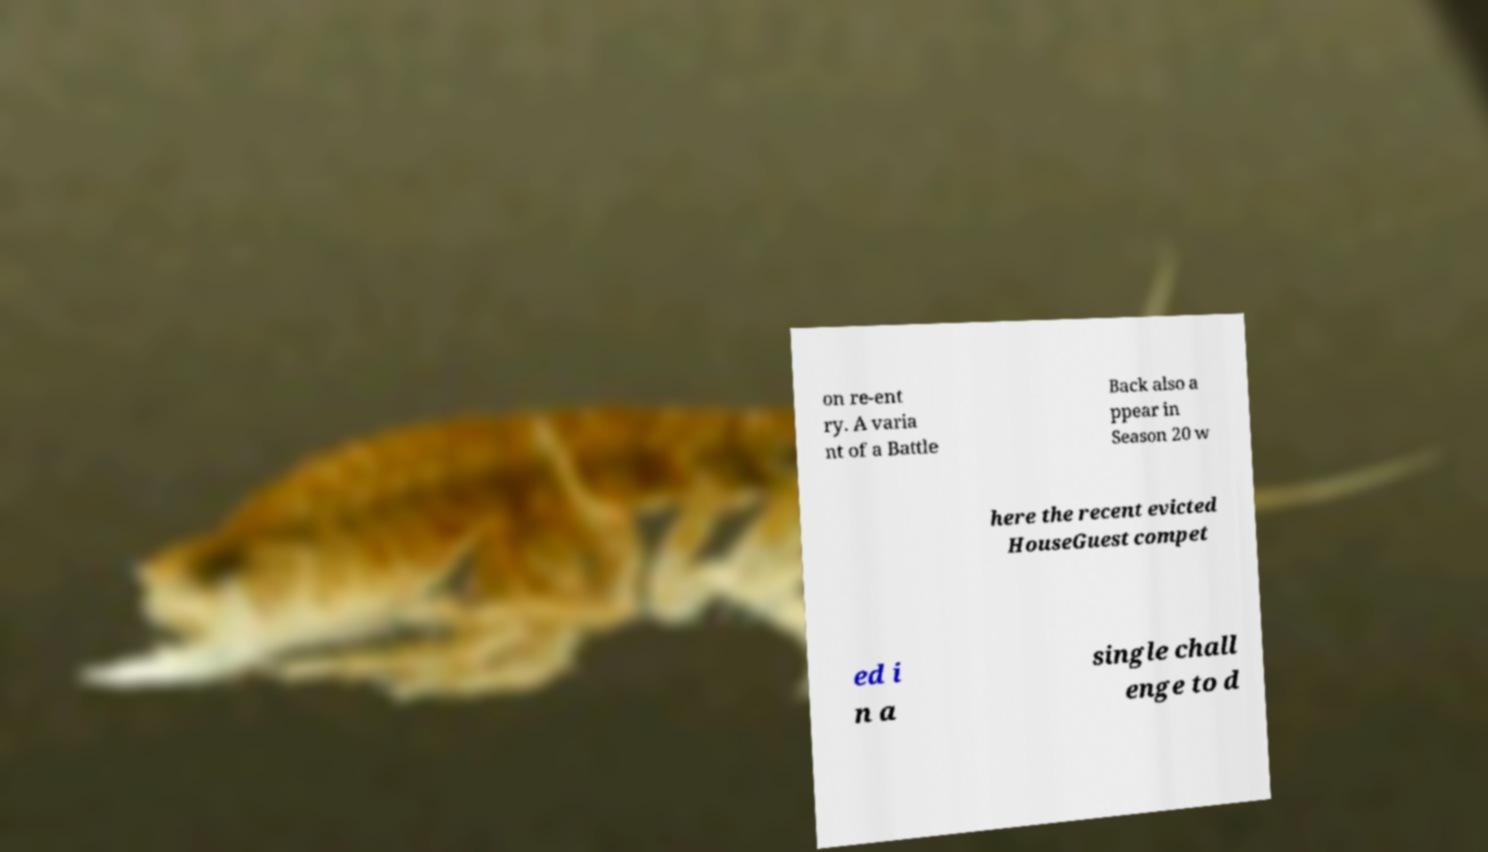Please read and relay the text visible in this image. What does it say? on re-ent ry. A varia nt of a Battle Back also a ppear in Season 20 w here the recent evicted HouseGuest compet ed i n a single chall enge to d 